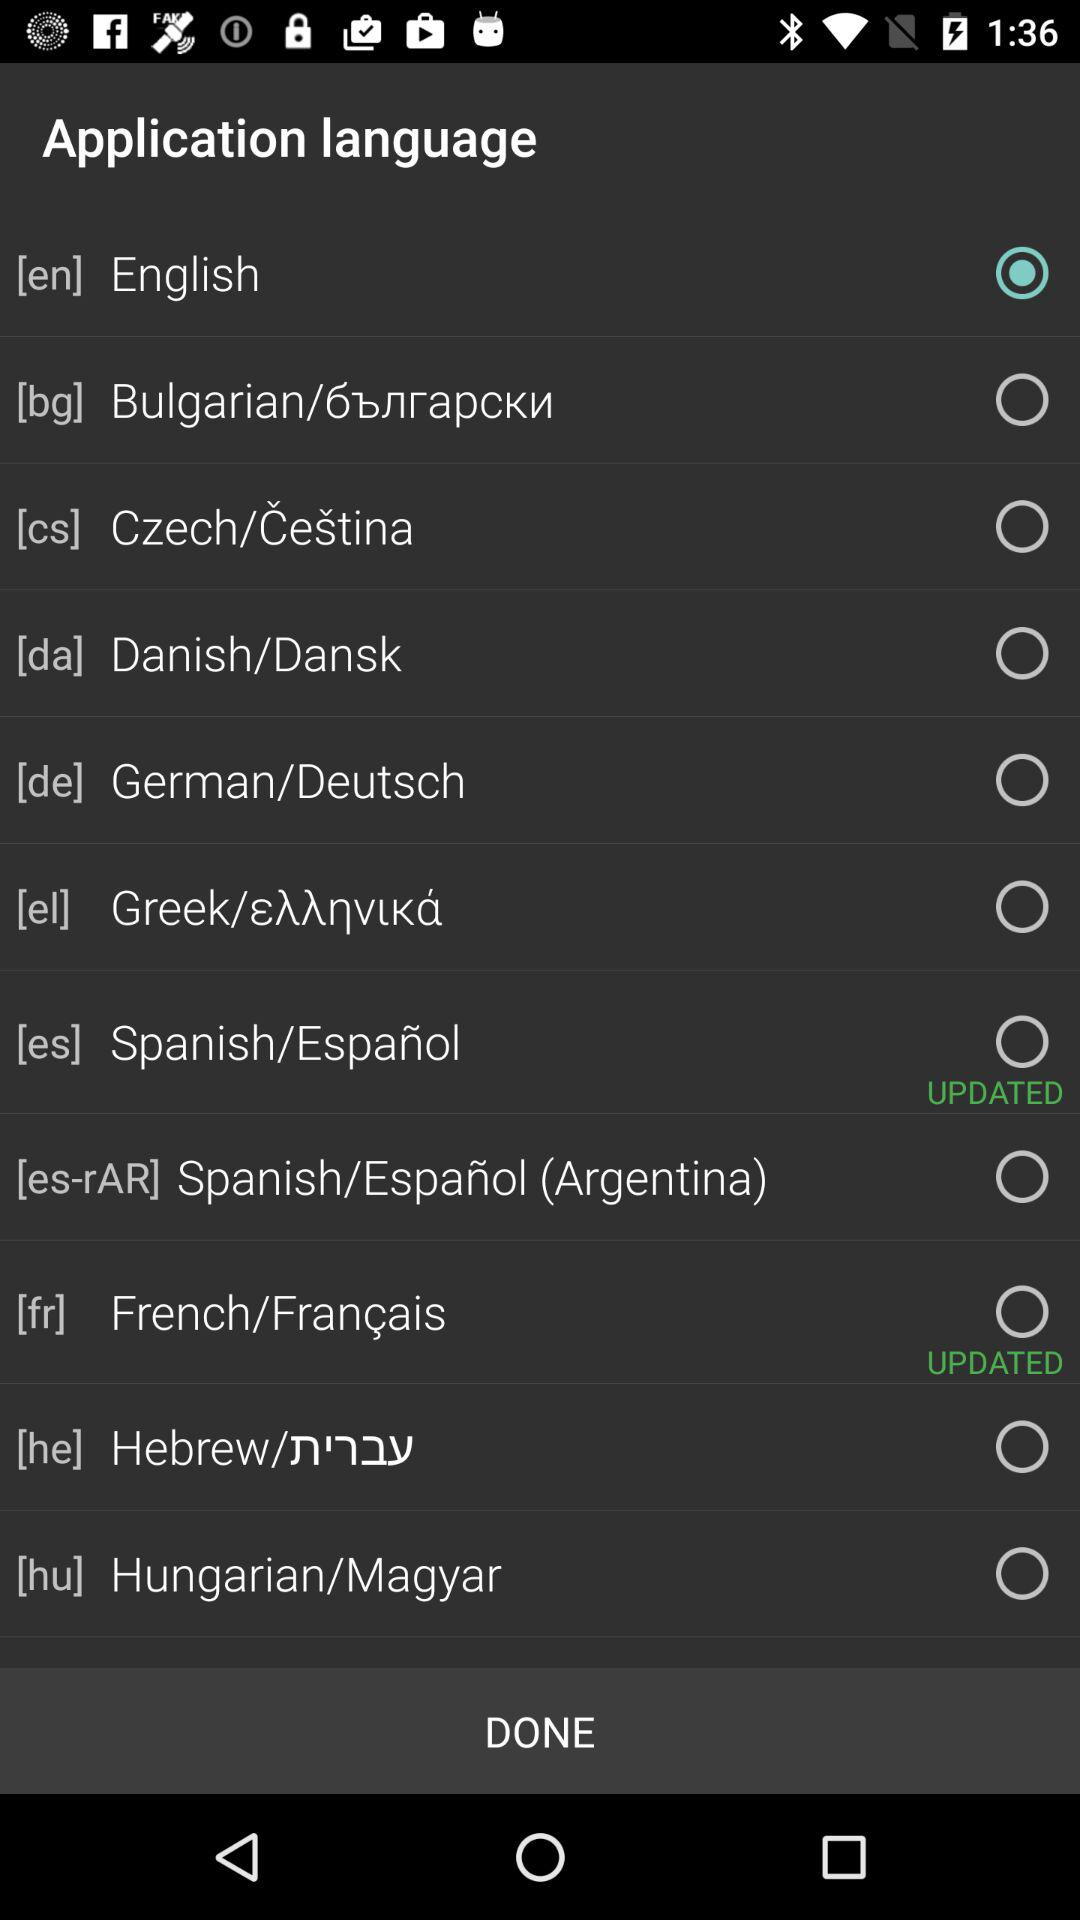How many languages have been updated?
Answer the question using a single word or phrase. 2 